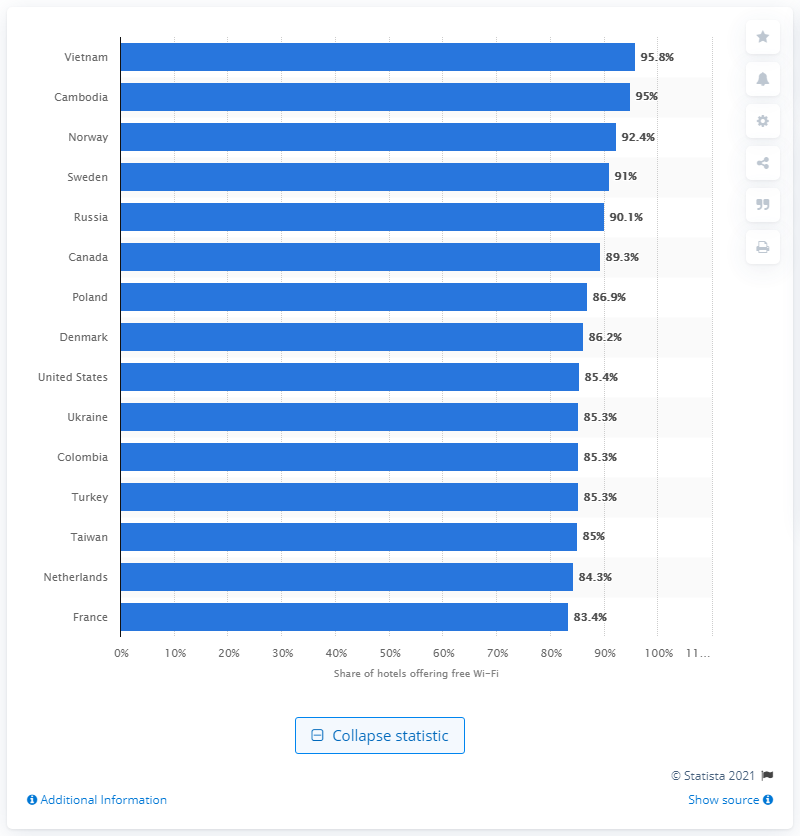Point out several critical features in this image. According to the ranking, Norway is third in terms of countries with the most hotels offering free Wi-Fi. According to the ranking of countries with the most hotels offering free Wi-Fi, Norway is third. 